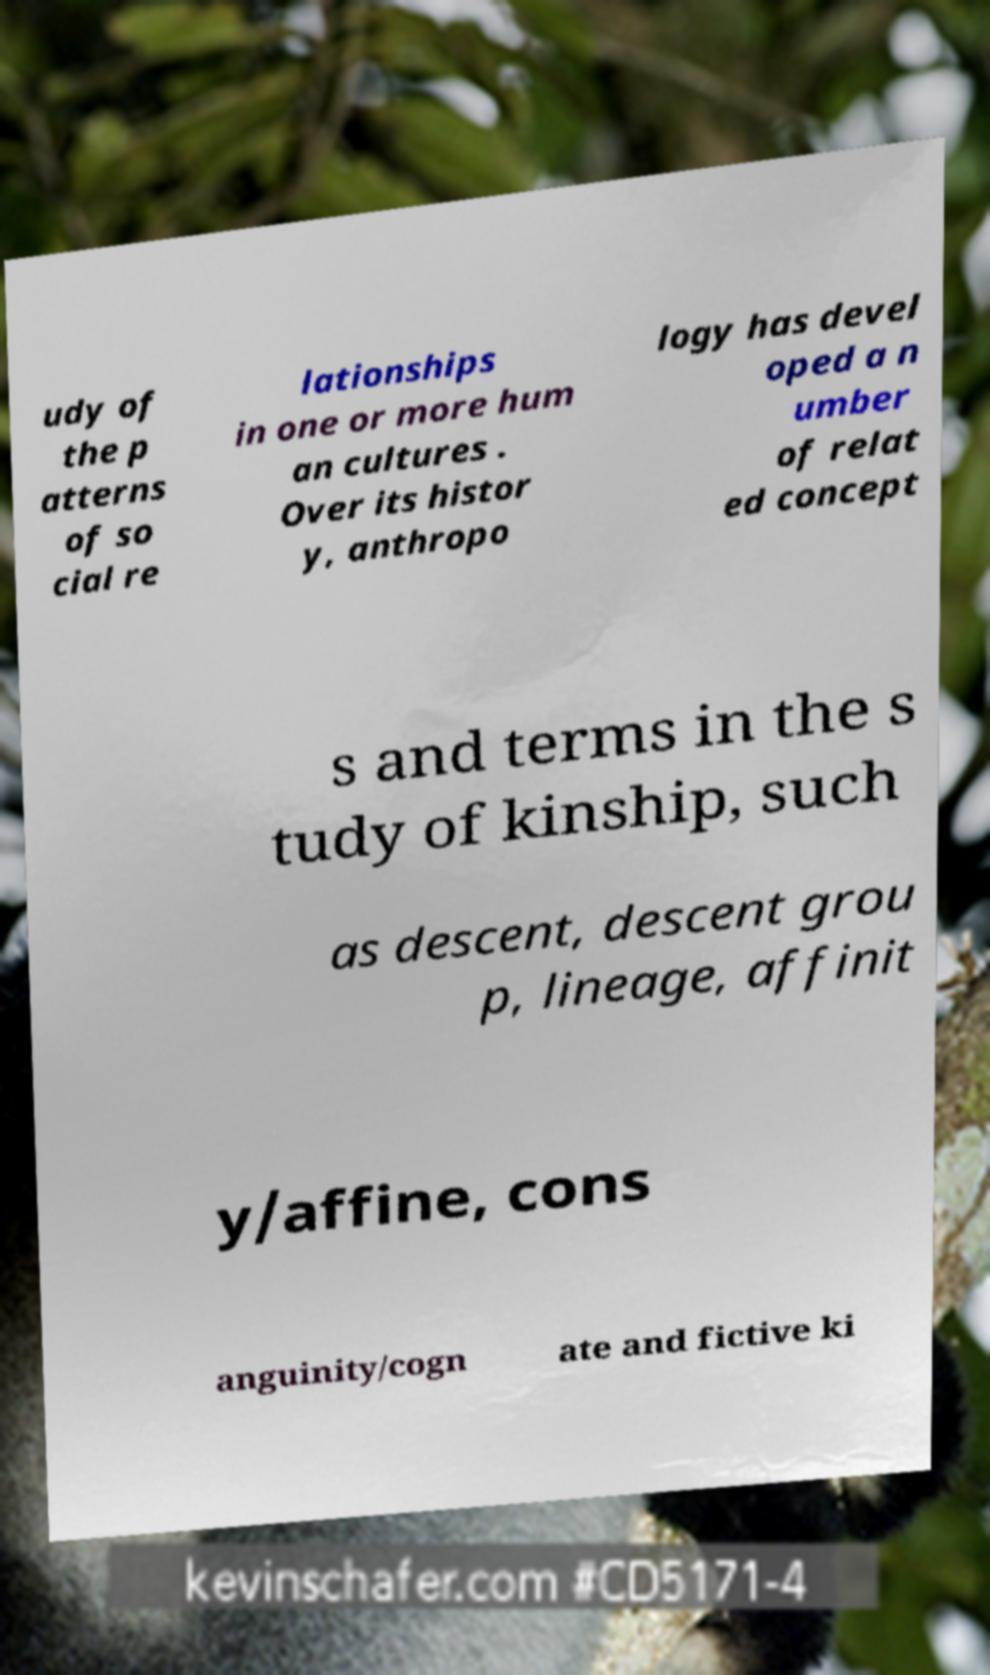There's text embedded in this image that I need extracted. Can you transcribe it verbatim? udy of the p atterns of so cial re lationships in one or more hum an cultures . Over its histor y, anthropo logy has devel oped a n umber of relat ed concept s and terms in the s tudy of kinship, such as descent, descent grou p, lineage, affinit y/affine, cons anguinity/cogn ate and fictive ki 